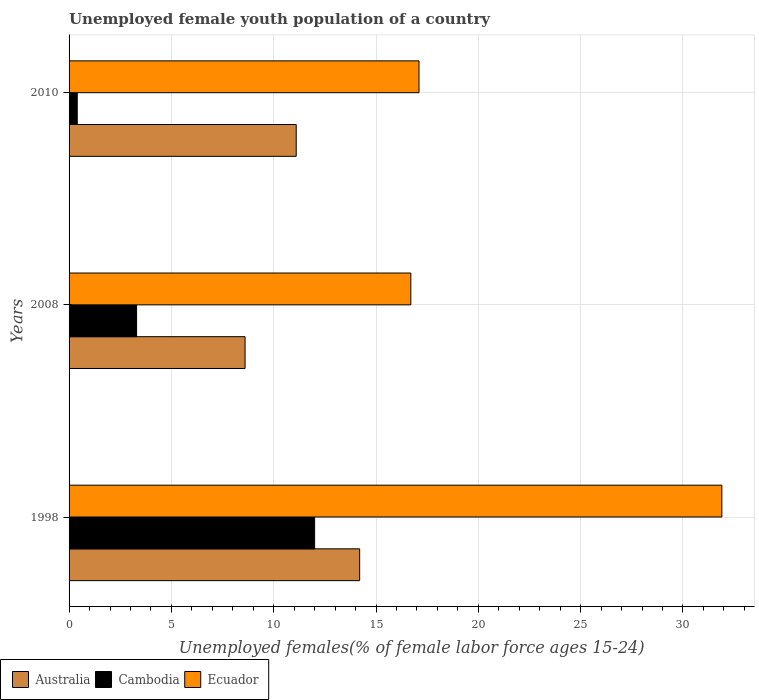How many different coloured bars are there?
Keep it short and to the point. 3. How many bars are there on the 3rd tick from the top?
Offer a terse response. 3. What is the label of the 2nd group of bars from the top?
Make the answer very short. 2008. What is the percentage of unemployed female youth population in Australia in 1998?
Offer a very short reply. 14.2. Across all years, what is the maximum percentage of unemployed female youth population in Australia?
Provide a short and direct response. 14.2. Across all years, what is the minimum percentage of unemployed female youth population in Ecuador?
Give a very brief answer. 16.7. In which year was the percentage of unemployed female youth population in Ecuador maximum?
Your response must be concise. 1998. What is the total percentage of unemployed female youth population in Ecuador in the graph?
Your answer should be compact. 65.7. What is the difference between the percentage of unemployed female youth population in Ecuador in 1998 and that in 2010?
Offer a terse response. 14.8. What is the difference between the percentage of unemployed female youth population in Cambodia in 2010 and the percentage of unemployed female youth population in Australia in 2008?
Make the answer very short. -8.2. What is the average percentage of unemployed female youth population in Ecuador per year?
Make the answer very short. 21.9. In the year 1998, what is the difference between the percentage of unemployed female youth population in Cambodia and percentage of unemployed female youth population in Ecuador?
Offer a very short reply. -19.9. What is the ratio of the percentage of unemployed female youth population in Cambodia in 1998 to that in 2008?
Your answer should be compact. 3.64. Is the percentage of unemployed female youth population in Australia in 1998 less than that in 2008?
Offer a terse response. No. What is the difference between the highest and the second highest percentage of unemployed female youth population in Ecuador?
Provide a succinct answer. 14.8. What is the difference between the highest and the lowest percentage of unemployed female youth population in Australia?
Your answer should be very brief. 5.6. In how many years, is the percentage of unemployed female youth population in Cambodia greater than the average percentage of unemployed female youth population in Cambodia taken over all years?
Offer a terse response. 1. Is the sum of the percentage of unemployed female youth population in Cambodia in 2008 and 2010 greater than the maximum percentage of unemployed female youth population in Australia across all years?
Provide a succinct answer. No. What does the 2nd bar from the bottom in 2010 represents?
Provide a succinct answer. Cambodia. How many bars are there?
Ensure brevity in your answer.  9. Are all the bars in the graph horizontal?
Provide a succinct answer. Yes. How are the legend labels stacked?
Keep it short and to the point. Horizontal. What is the title of the graph?
Provide a succinct answer. Unemployed female youth population of a country. What is the label or title of the X-axis?
Your answer should be compact. Unemployed females(% of female labor force ages 15-24). What is the Unemployed females(% of female labor force ages 15-24) in Australia in 1998?
Provide a short and direct response. 14.2. What is the Unemployed females(% of female labor force ages 15-24) of Cambodia in 1998?
Your answer should be very brief. 12. What is the Unemployed females(% of female labor force ages 15-24) in Ecuador in 1998?
Your answer should be compact. 31.9. What is the Unemployed females(% of female labor force ages 15-24) in Australia in 2008?
Provide a succinct answer. 8.6. What is the Unemployed females(% of female labor force ages 15-24) of Cambodia in 2008?
Your answer should be very brief. 3.3. What is the Unemployed females(% of female labor force ages 15-24) in Ecuador in 2008?
Offer a very short reply. 16.7. What is the Unemployed females(% of female labor force ages 15-24) of Australia in 2010?
Offer a very short reply. 11.1. What is the Unemployed females(% of female labor force ages 15-24) in Cambodia in 2010?
Offer a very short reply. 0.4. What is the Unemployed females(% of female labor force ages 15-24) of Ecuador in 2010?
Offer a terse response. 17.1. Across all years, what is the maximum Unemployed females(% of female labor force ages 15-24) in Australia?
Ensure brevity in your answer.  14.2. Across all years, what is the maximum Unemployed females(% of female labor force ages 15-24) of Ecuador?
Make the answer very short. 31.9. Across all years, what is the minimum Unemployed females(% of female labor force ages 15-24) in Australia?
Give a very brief answer. 8.6. Across all years, what is the minimum Unemployed females(% of female labor force ages 15-24) in Cambodia?
Provide a succinct answer. 0.4. Across all years, what is the minimum Unemployed females(% of female labor force ages 15-24) in Ecuador?
Keep it short and to the point. 16.7. What is the total Unemployed females(% of female labor force ages 15-24) in Australia in the graph?
Give a very brief answer. 33.9. What is the total Unemployed females(% of female labor force ages 15-24) in Cambodia in the graph?
Provide a succinct answer. 15.7. What is the total Unemployed females(% of female labor force ages 15-24) in Ecuador in the graph?
Offer a terse response. 65.7. What is the difference between the Unemployed females(% of female labor force ages 15-24) of Cambodia in 1998 and that in 2008?
Your answer should be very brief. 8.7. What is the difference between the Unemployed females(% of female labor force ages 15-24) in Australia in 1998 and that in 2010?
Provide a short and direct response. 3.1. What is the difference between the Unemployed females(% of female labor force ages 15-24) of Cambodia in 2008 and that in 2010?
Make the answer very short. 2.9. What is the difference between the Unemployed females(% of female labor force ages 15-24) of Australia in 1998 and the Unemployed females(% of female labor force ages 15-24) of Cambodia in 2008?
Your answer should be very brief. 10.9. What is the difference between the Unemployed females(% of female labor force ages 15-24) in Australia in 1998 and the Unemployed females(% of female labor force ages 15-24) in Ecuador in 2008?
Your answer should be very brief. -2.5. What is the difference between the Unemployed females(% of female labor force ages 15-24) of Cambodia in 1998 and the Unemployed females(% of female labor force ages 15-24) of Ecuador in 2008?
Your response must be concise. -4.7. What is the difference between the Unemployed females(% of female labor force ages 15-24) in Australia in 1998 and the Unemployed females(% of female labor force ages 15-24) in Cambodia in 2010?
Give a very brief answer. 13.8. What is the average Unemployed females(% of female labor force ages 15-24) of Cambodia per year?
Ensure brevity in your answer.  5.23. What is the average Unemployed females(% of female labor force ages 15-24) in Ecuador per year?
Provide a succinct answer. 21.9. In the year 1998, what is the difference between the Unemployed females(% of female labor force ages 15-24) of Australia and Unemployed females(% of female labor force ages 15-24) of Ecuador?
Give a very brief answer. -17.7. In the year 1998, what is the difference between the Unemployed females(% of female labor force ages 15-24) of Cambodia and Unemployed females(% of female labor force ages 15-24) of Ecuador?
Your answer should be compact. -19.9. In the year 2008, what is the difference between the Unemployed females(% of female labor force ages 15-24) in Australia and Unemployed females(% of female labor force ages 15-24) in Cambodia?
Offer a very short reply. 5.3. In the year 2008, what is the difference between the Unemployed females(% of female labor force ages 15-24) in Australia and Unemployed females(% of female labor force ages 15-24) in Ecuador?
Make the answer very short. -8.1. In the year 2010, what is the difference between the Unemployed females(% of female labor force ages 15-24) of Australia and Unemployed females(% of female labor force ages 15-24) of Cambodia?
Offer a very short reply. 10.7. In the year 2010, what is the difference between the Unemployed females(% of female labor force ages 15-24) in Cambodia and Unemployed females(% of female labor force ages 15-24) in Ecuador?
Offer a very short reply. -16.7. What is the ratio of the Unemployed females(% of female labor force ages 15-24) in Australia in 1998 to that in 2008?
Ensure brevity in your answer.  1.65. What is the ratio of the Unemployed females(% of female labor force ages 15-24) in Cambodia in 1998 to that in 2008?
Your response must be concise. 3.64. What is the ratio of the Unemployed females(% of female labor force ages 15-24) in Ecuador in 1998 to that in 2008?
Your answer should be very brief. 1.91. What is the ratio of the Unemployed females(% of female labor force ages 15-24) of Australia in 1998 to that in 2010?
Provide a succinct answer. 1.28. What is the ratio of the Unemployed females(% of female labor force ages 15-24) in Ecuador in 1998 to that in 2010?
Provide a short and direct response. 1.87. What is the ratio of the Unemployed females(% of female labor force ages 15-24) of Australia in 2008 to that in 2010?
Make the answer very short. 0.77. What is the ratio of the Unemployed females(% of female labor force ages 15-24) in Cambodia in 2008 to that in 2010?
Offer a very short reply. 8.25. What is the ratio of the Unemployed females(% of female labor force ages 15-24) of Ecuador in 2008 to that in 2010?
Your answer should be very brief. 0.98. What is the difference between the highest and the second highest Unemployed females(% of female labor force ages 15-24) of Australia?
Provide a short and direct response. 3.1. What is the difference between the highest and the second highest Unemployed females(% of female labor force ages 15-24) in Ecuador?
Your response must be concise. 14.8. What is the difference between the highest and the lowest Unemployed females(% of female labor force ages 15-24) of Australia?
Make the answer very short. 5.6. What is the difference between the highest and the lowest Unemployed females(% of female labor force ages 15-24) in Ecuador?
Make the answer very short. 15.2. 